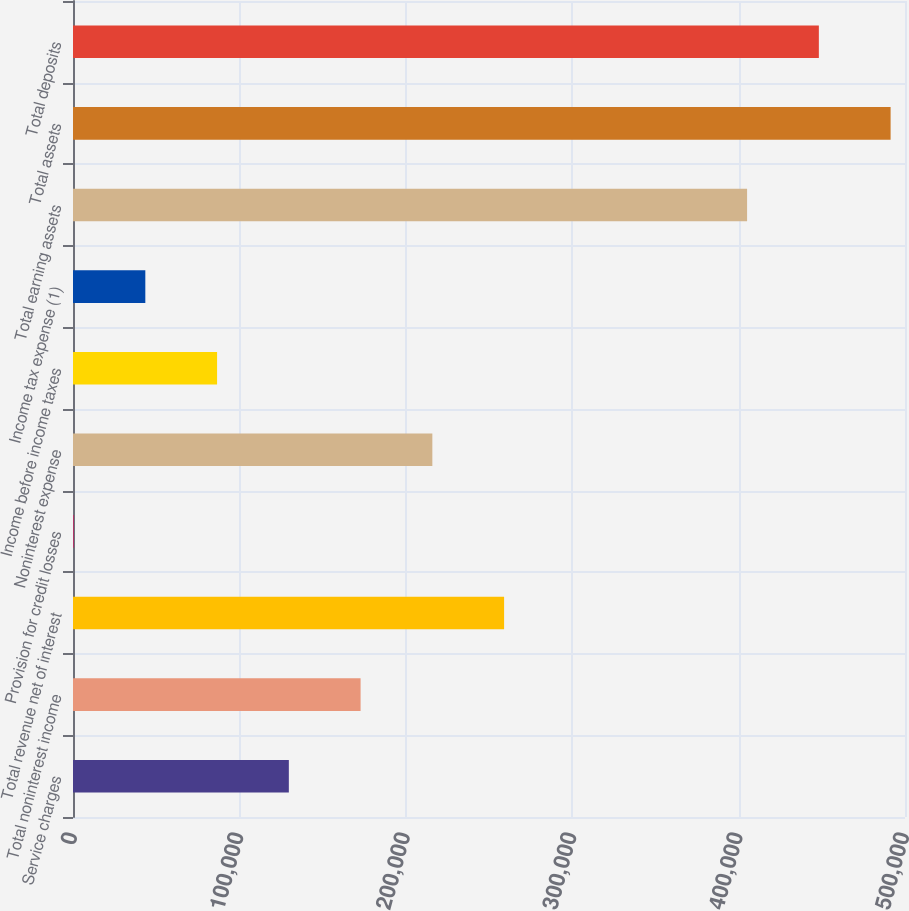<chart> <loc_0><loc_0><loc_500><loc_500><bar_chart><fcel>Service charges<fcel>Total noninterest income<fcel>Total revenue net of interest<fcel>Provision for credit losses<fcel>Noninterest expense<fcel>Income before income taxes<fcel>Income tax expense (1)<fcel>Total earning assets<fcel>Total assets<fcel>Total deposits<nl><fcel>129709<fcel>172831<fcel>259076<fcel>343<fcel>215954<fcel>86587.2<fcel>43465.1<fcel>405104<fcel>491348<fcel>448226<nl></chart> 